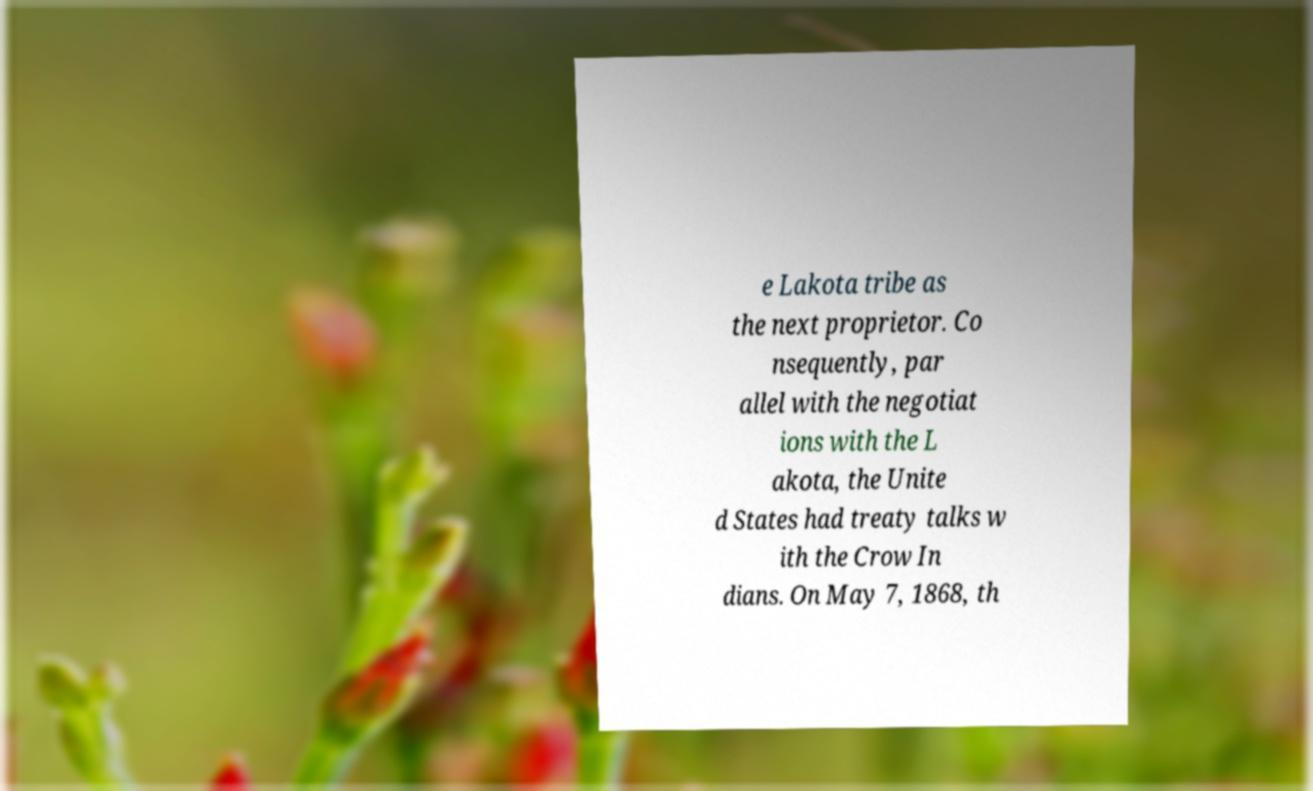Could you assist in decoding the text presented in this image and type it out clearly? e Lakota tribe as the next proprietor. Co nsequently, par allel with the negotiat ions with the L akota, the Unite d States had treaty talks w ith the Crow In dians. On May 7, 1868, th 